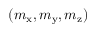<formula> <loc_0><loc_0><loc_500><loc_500>( m _ { x } , m _ { y } , m _ { z } )</formula> 